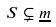<formula> <loc_0><loc_0><loc_500><loc_500>S \subsetneq \underline { m }</formula> 